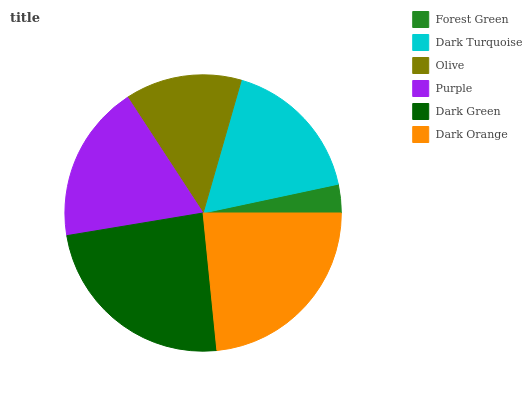Is Forest Green the minimum?
Answer yes or no. Yes. Is Dark Green the maximum?
Answer yes or no. Yes. Is Dark Turquoise the minimum?
Answer yes or no. No. Is Dark Turquoise the maximum?
Answer yes or no. No. Is Dark Turquoise greater than Forest Green?
Answer yes or no. Yes. Is Forest Green less than Dark Turquoise?
Answer yes or no. Yes. Is Forest Green greater than Dark Turquoise?
Answer yes or no. No. Is Dark Turquoise less than Forest Green?
Answer yes or no. No. Is Purple the high median?
Answer yes or no. Yes. Is Dark Turquoise the low median?
Answer yes or no. Yes. Is Olive the high median?
Answer yes or no. No. Is Dark Orange the low median?
Answer yes or no. No. 